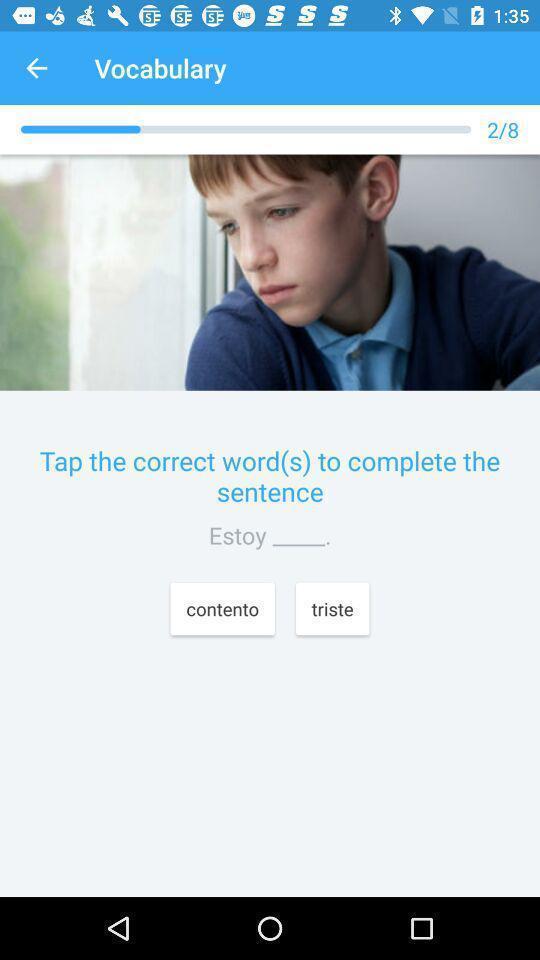Describe the content in this image. Vocabulary page with question displayed in an language learning application. 